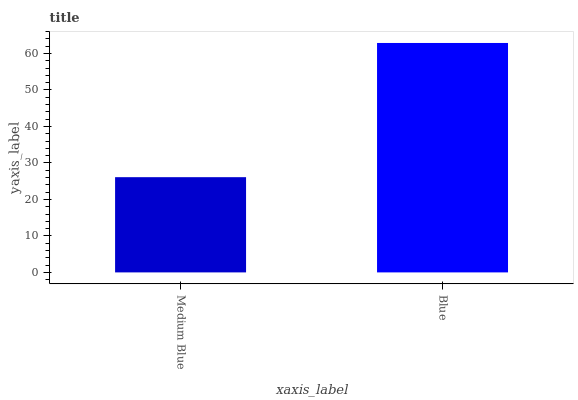Is Medium Blue the minimum?
Answer yes or no. Yes. Is Blue the maximum?
Answer yes or no. Yes. Is Blue the minimum?
Answer yes or no. No. Is Blue greater than Medium Blue?
Answer yes or no. Yes. Is Medium Blue less than Blue?
Answer yes or no. Yes. Is Medium Blue greater than Blue?
Answer yes or no. No. Is Blue less than Medium Blue?
Answer yes or no. No. Is Blue the high median?
Answer yes or no. Yes. Is Medium Blue the low median?
Answer yes or no. Yes. Is Medium Blue the high median?
Answer yes or no. No. Is Blue the low median?
Answer yes or no. No. 